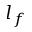Convert formula to latex. <formula><loc_0><loc_0><loc_500><loc_500>l _ { f }</formula> 